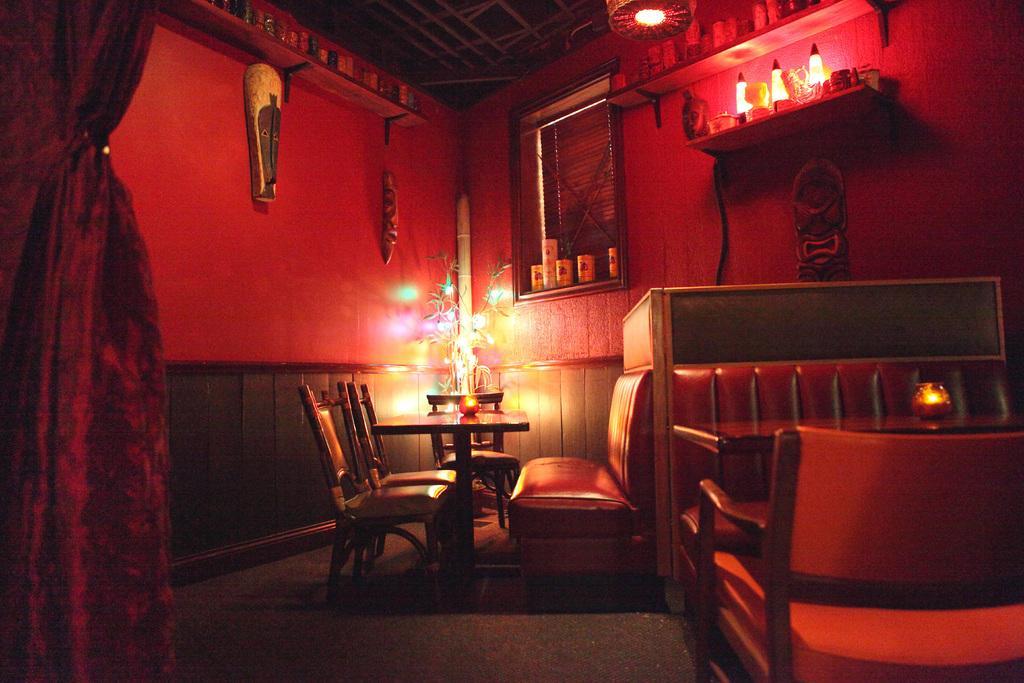Please provide a concise description of this image. This image is clicked in a room. In the front, we can see the tables and chairs. At the bottom, there is a floor. On the left, there is a curtain. At the top, there is a roof along with a light. In the front, there is a wall in red color. 